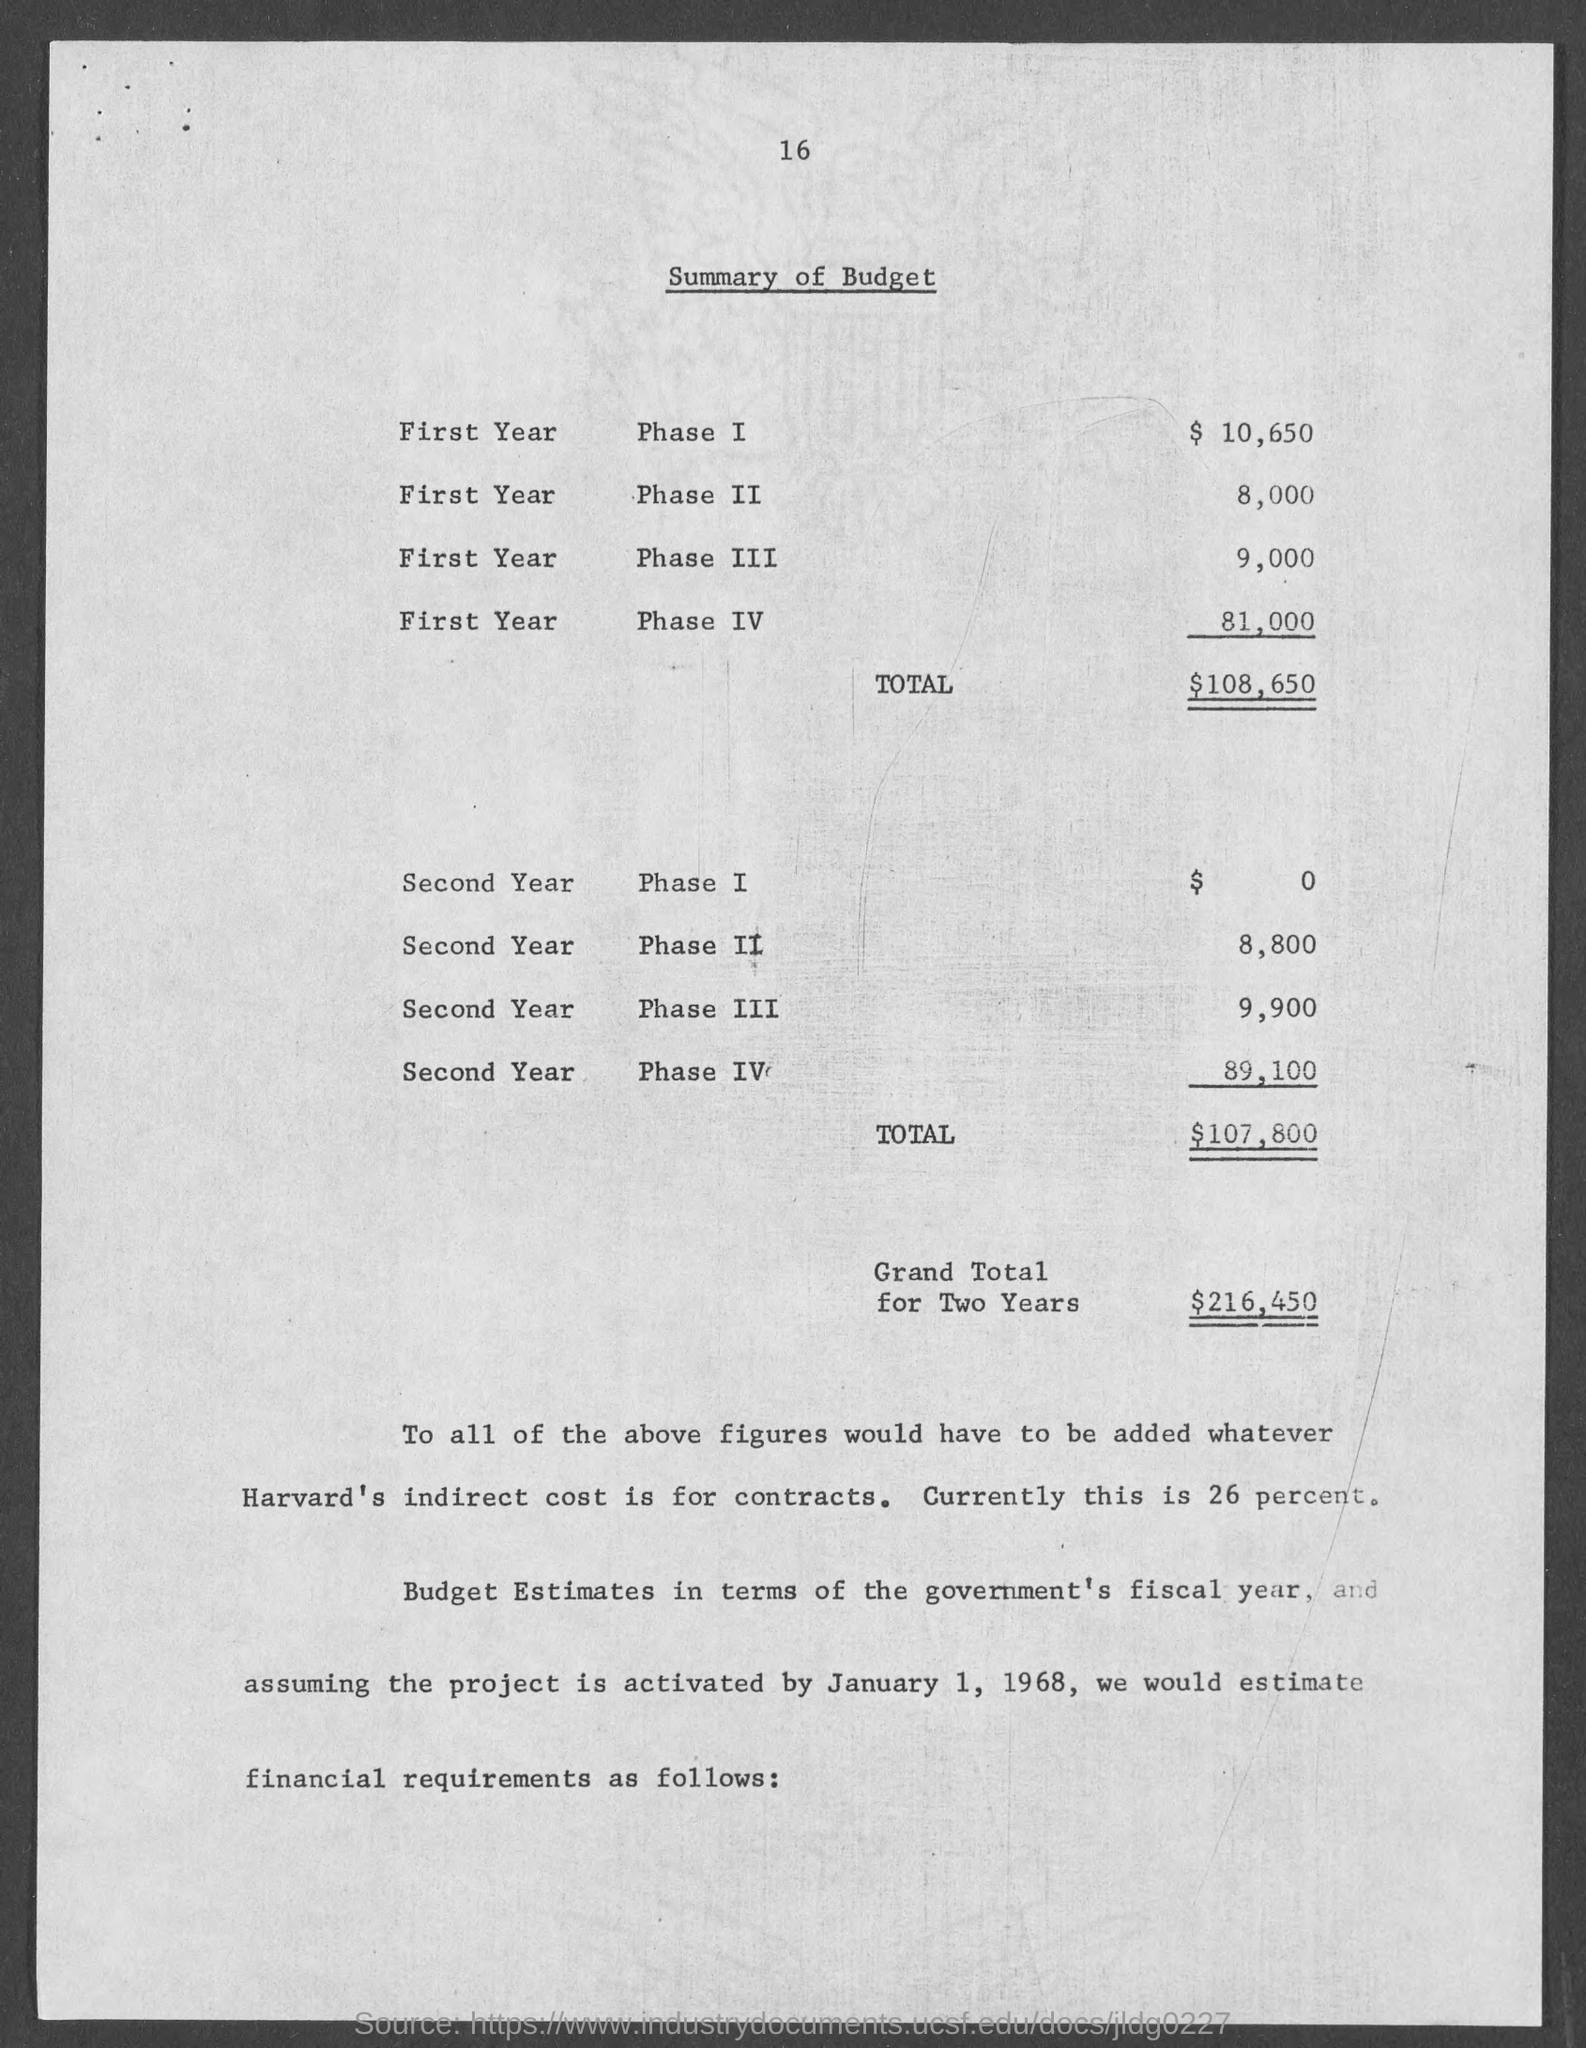Indicate a few pertinent items in this graphic. In the second year of phase 3, the allocated budget was 9,900. The total budget for the first year is $108,650. The budget allocated in phase 4 of the first year is R81,000. The amount of budget in phase 1 for the first year is 10,650. The amount of budget given in Phase 1 in the second year is 0. 